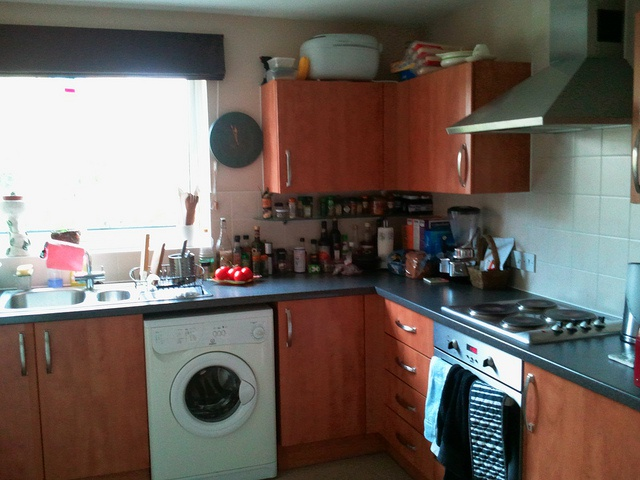Describe the objects in this image and their specific colors. I can see oven in gray, black, white, blue, and purple tones, sink in gray, white, darkgray, and lightblue tones, clock in gray, black, and purple tones, vase in gray, lightgray, lightblue, and darkgray tones, and bottle in gray, darkgray, and maroon tones in this image. 